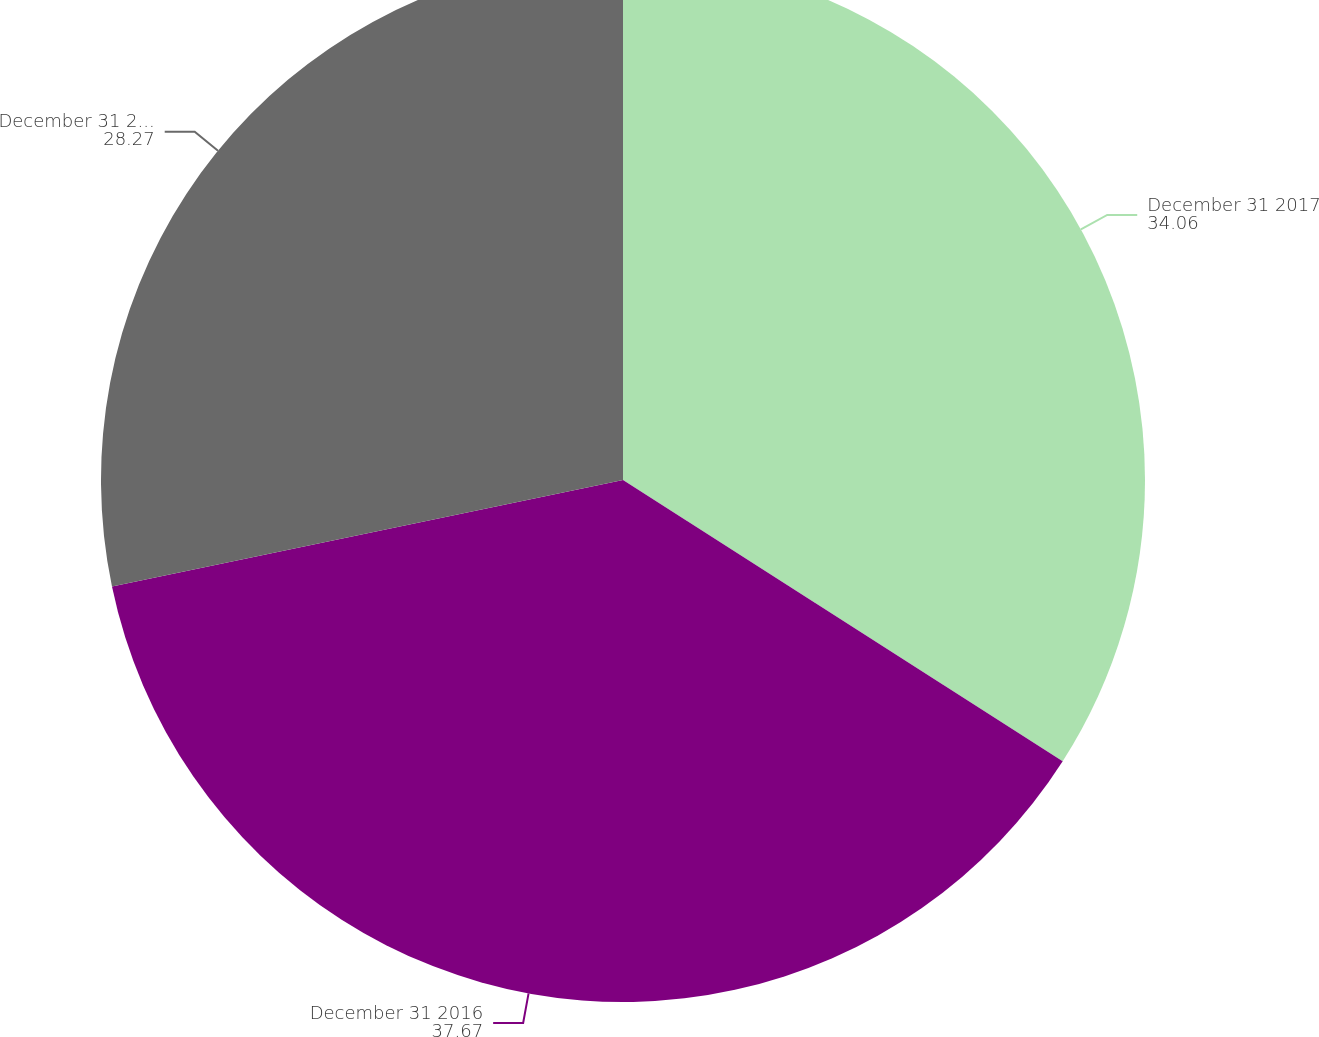Convert chart. <chart><loc_0><loc_0><loc_500><loc_500><pie_chart><fcel>December 31 2017<fcel>December 31 2016<fcel>December 31 2015<nl><fcel>34.06%<fcel>37.67%<fcel>28.27%<nl></chart> 